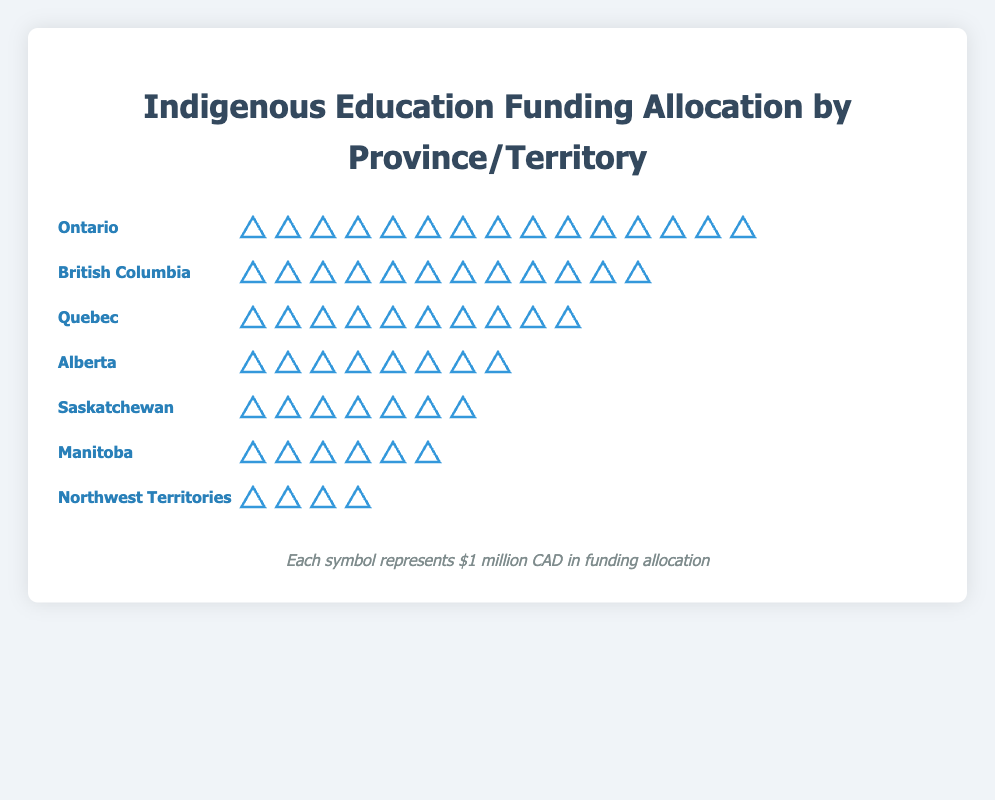Which province or territory receives the highest funding for indigenous-focused programs? Look for the province or territory with the largest number of symbols representing funding units. Ontario has 15 symbols, the highest among all.
Answer: Ontario How much funding does Alberta receive for indigenous-focused programs in comparison to Saskatchewan? Count the symbols for both Alberta and Saskatchewan. Alberta has 8 symbols, and Saskatchewan has 7 symbols. The difference is 8 - 7 = 1 symbol or $1 million CAD.
Answer: $1 million CAD more Which provinces or territories have less than 10 funding units? Count the units for each region and identify those with fewer than 10 symbols. Alberta (8), Manitoba (6), Saskatchewan (7), and Northwest Territories (4) all have fewer than 10 symbols.
Answer: Alberta, Manitoba, Saskatchewan, Northwest Territories What is the total funding for indigenous-focused programs across all the provinces and territories? Sum the number of symbols across all listed regions: Ontario (15) + British Columbia (12) + Quebec (10) + Alberta (8) + Saskatchewan (7) + Manitoba (6) + Northwest Territories (4). This equals 62 funding units. Since each unit is $1 million CAD, the total funding is 62 million CAD.
Answer: $62 million CAD How does the funding for British Columbia compare to Quebec? Count the units for both British Columbia and Quebec. British Columbia has 12 units, Quebec has 10 units. British Columbia receives 2 units more.
Answer: $2 million CAD more Which province or territory receives the least funding? Identify the region with the fewest number of symbols. The Northwest Territories has the lowest number with 4 symbols.
Answer: Northwest Territories What is the average funding allocation per province or territory? Sum the total funding units and divide by the number of regions: (15 + 12 + 10 + 8 + 7 + 6 + 4) / 7. This equals 62 / 7, which is about 8.86 units. Convert to dollar value since each unit represents $1 million CAD.
Answer: $8.86 million CAD What is the combined funding for Alberta, Saskatchewan, and Manitoba? Sum the number of symbols for Alberta (8), Saskatchewan (7), and Manitoba (6). This equals 8 + 7 + 6 = 21 funding units. Convert to dollar value since each unit represents $1 million CAD.
Answer: $21 million CAD How many more funding units does Ontario receive compared to Manitoba? Count the units for Ontario and Manitoba. Ontario has 15 units, Manitoba has 6 units. The difference is 15 - 6 = 9 units. Convert to dollar value since each unit represents $1 million CAD.
Answer: $9 million CAD 